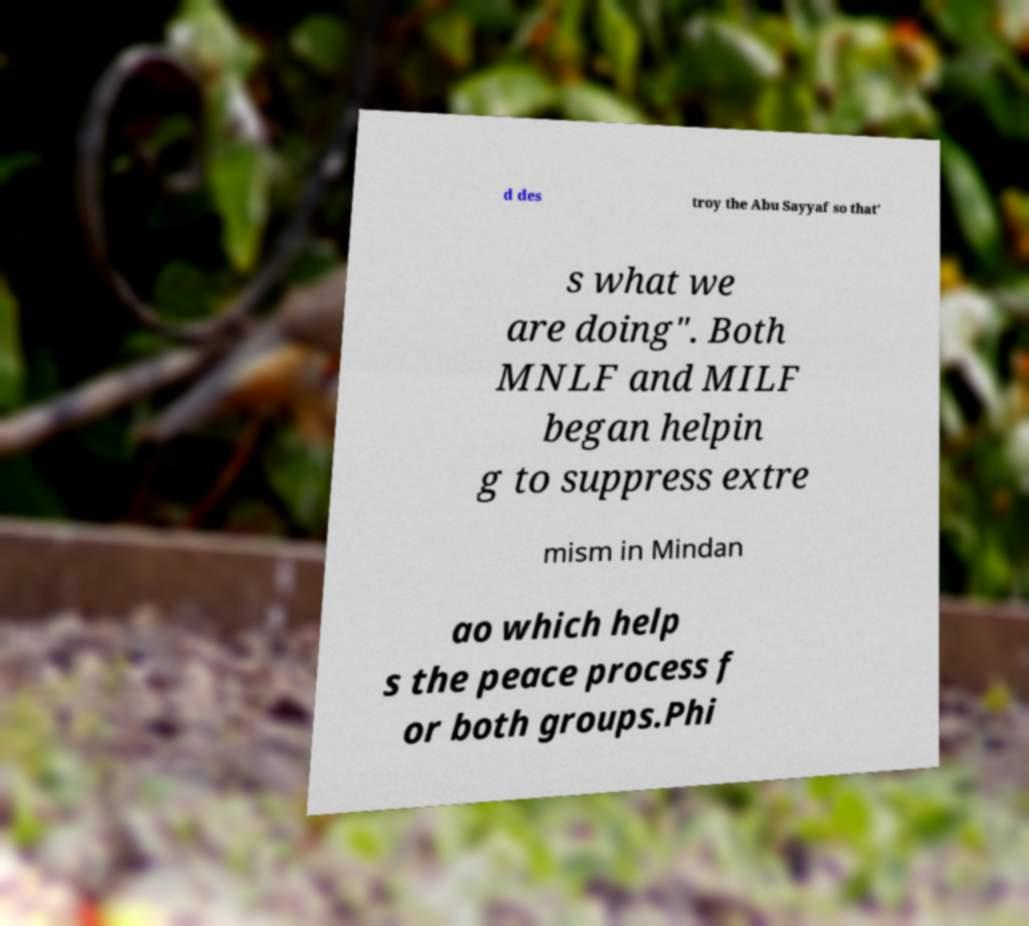Please read and relay the text visible in this image. What does it say? d des troy the Abu Sayyaf so that' s what we are doing". Both MNLF and MILF began helpin g to suppress extre mism in Mindan ao which help s the peace process f or both groups.Phi 